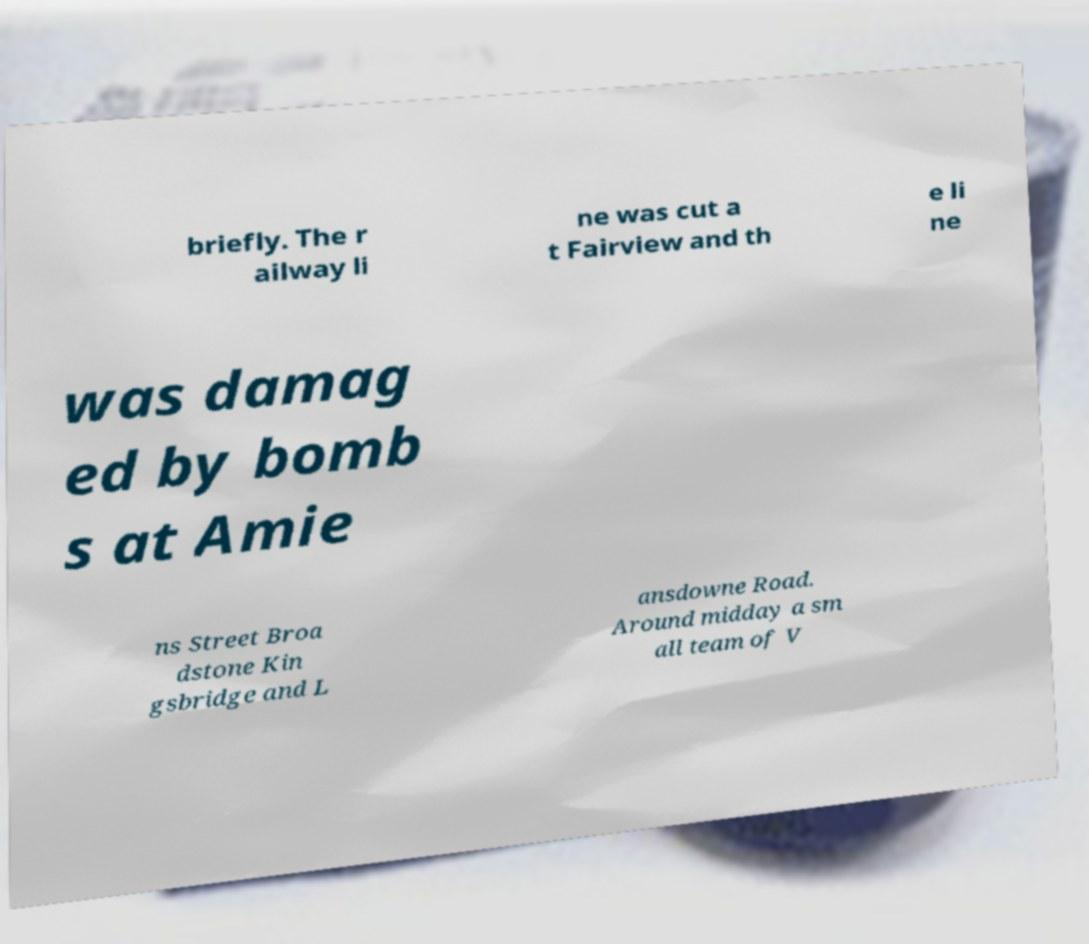I need the written content from this picture converted into text. Can you do that? briefly. The r ailway li ne was cut a t Fairview and th e li ne was damag ed by bomb s at Amie ns Street Broa dstone Kin gsbridge and L ansdowne Road. Around midday a sm all team of V 